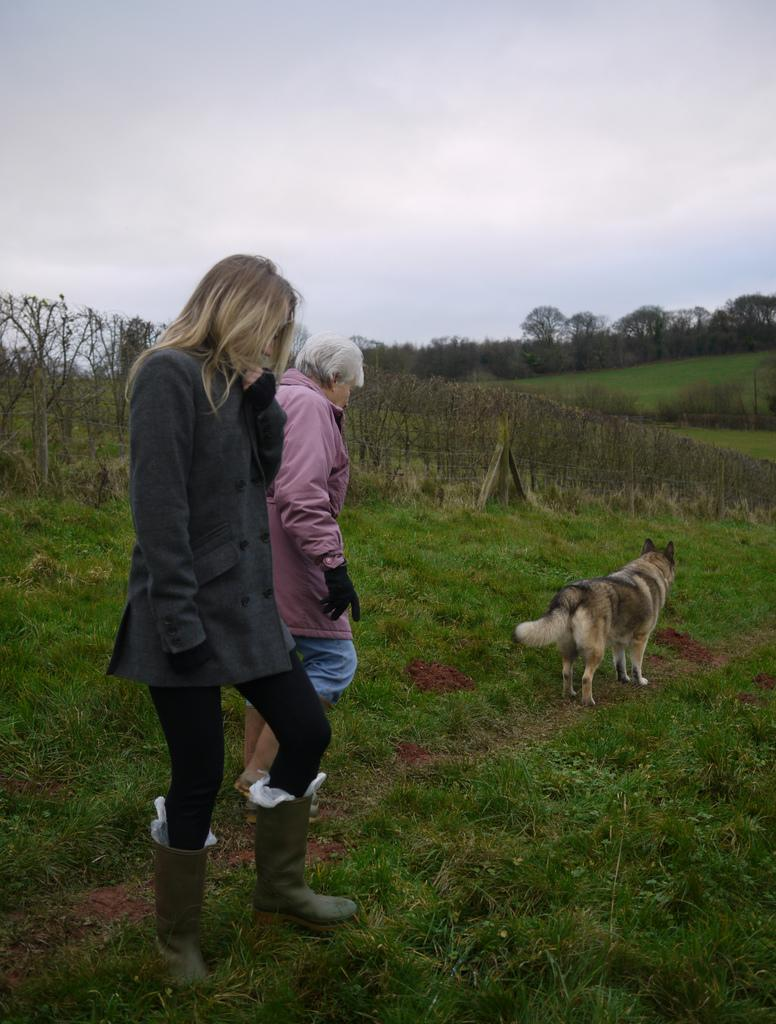How many people are in the image? There are two ladies in the image. What other living creature is present in the image? There is a dog in the image. What type of vegetation can be seen in the image? There are trees, plants, and grass in the image. What part of the natural environment is visible in the image? The sky is visible in the image. How many wheels can be seen on the dog in the image? There are no wheels present on the dog in the image. What type of pocket is visible on the lady's clothing in the image? There is no pocket visible on the ladies' clothing in the image. 